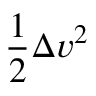Convert formula to latex. <formula><loc_0><loc_0><loc_500><loc_500>{ \frac { 1 } { 2 } } \Delta v ^ { 2 }</formula> 